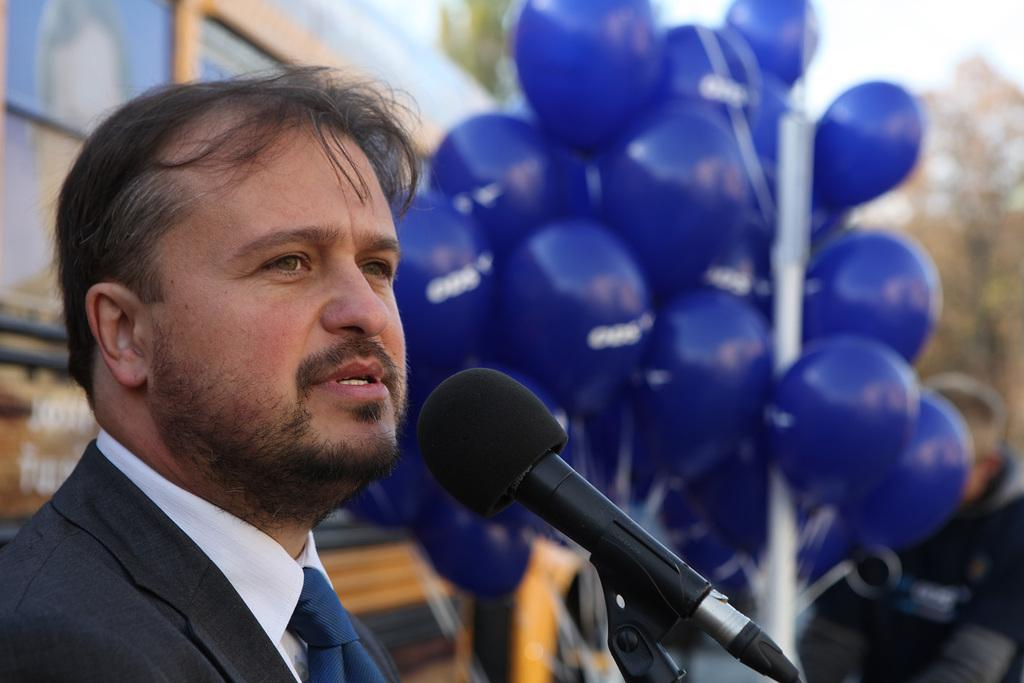Who is present in the image? There is a man in the image. What is the man doing in the image? The man is standing and speaking with the help of a microphone. What can be seen in the background of the image? There are trees visible in the image. What color are the balloons attached to the pole in the image? The balloons are violet in color. What news is the man sharing on the swing in the image? There is no swing present in the image, and the man is not sharing any news; he is speaking with a microphone. 